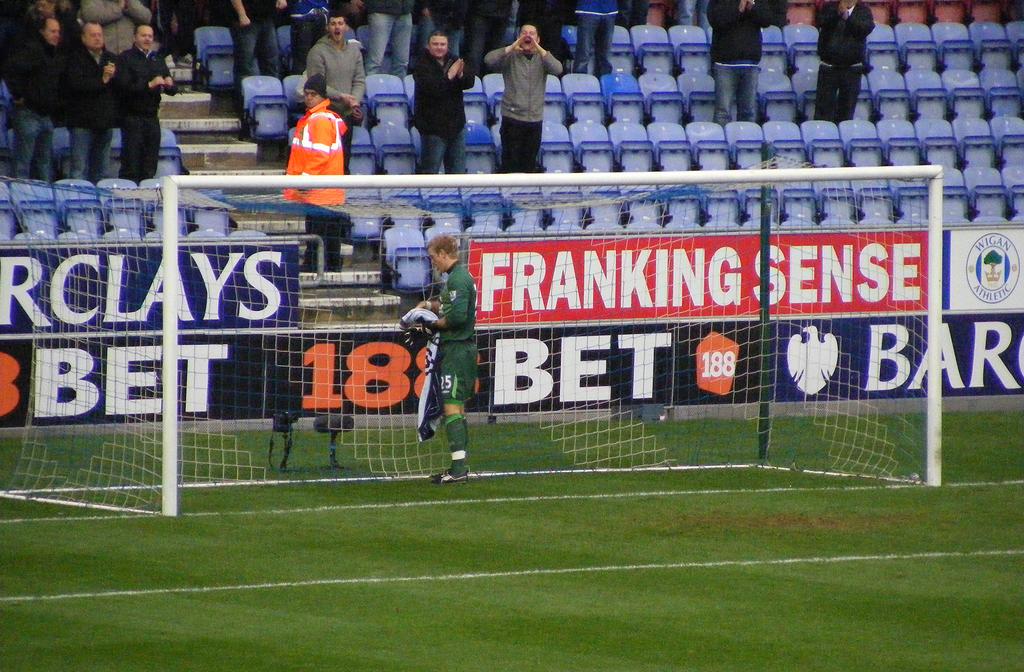What number comes before bet?
Provide a succinct answer. 188. 